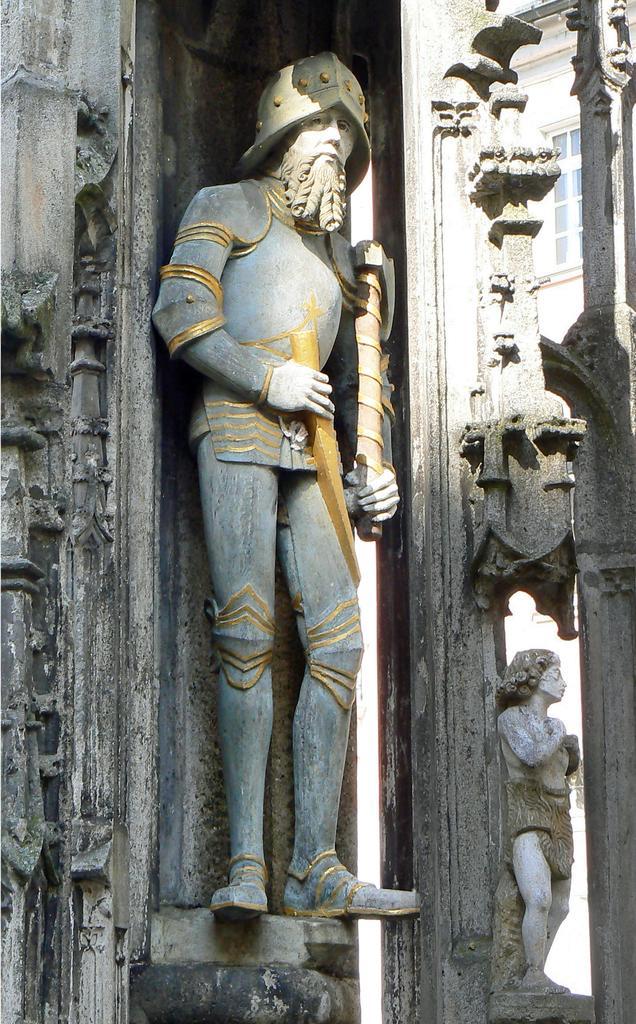Describe this image in one or two sentences. In this image, I can see the statue of a person standing. On the right side of the image, I can see another statue. I think these are the designs, which are carved on the stones. In the background, that looks like a window with a glass door. 